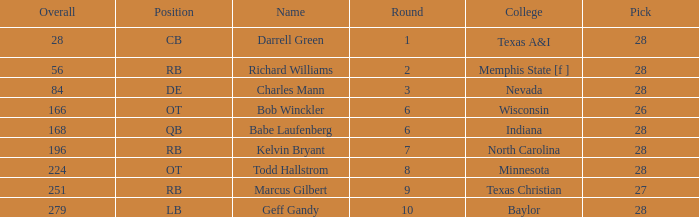What is the average round of the player from the college of baylor with a pick less than 28? None. 